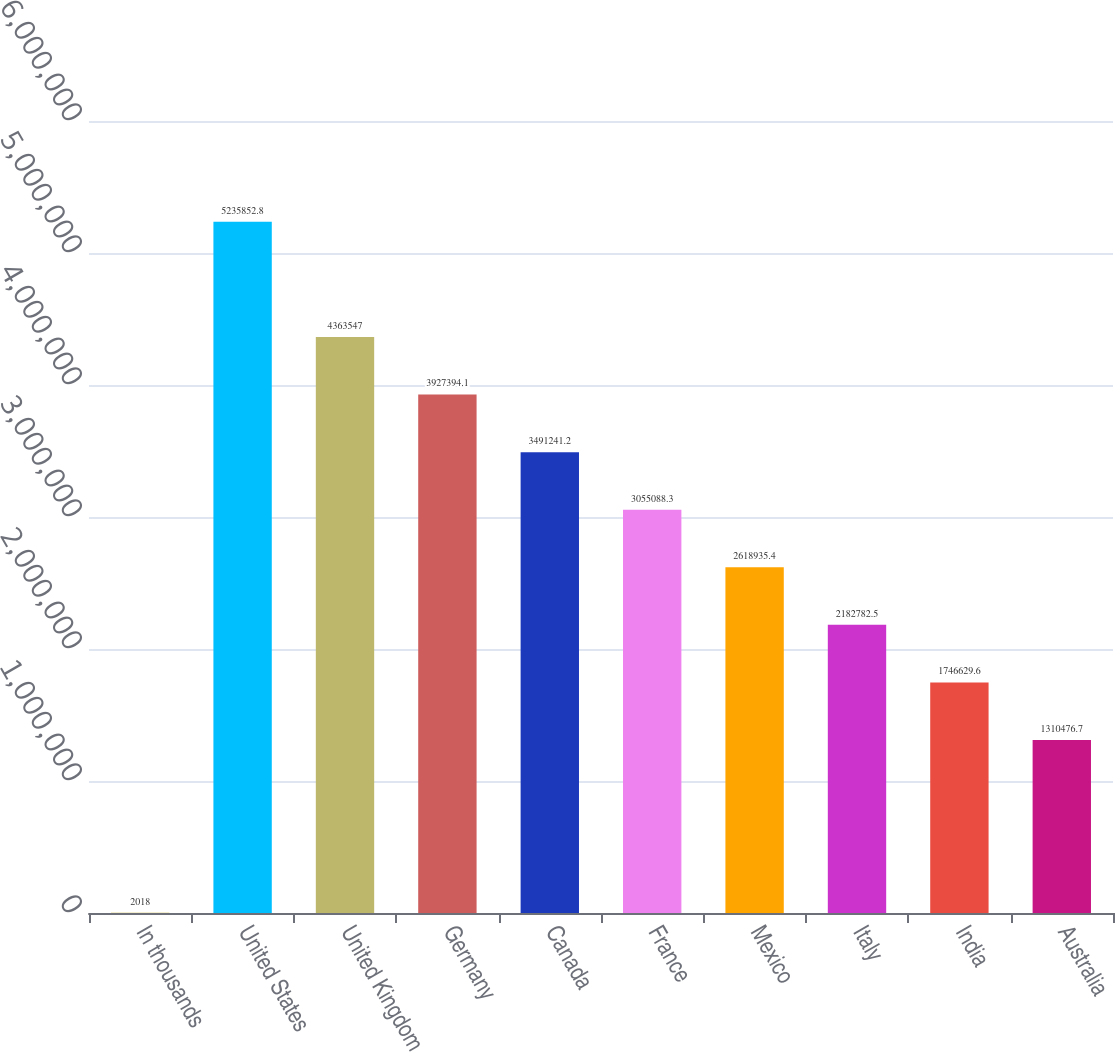Convert chart to OTSL. <chart><loc_0><loc_0><loc_500><loc_500><bar_chart><fcel>In thousands<fcel>United States<fcel>United Kingdom<fcel>Germany<fcel>Canada<fcel>France<fcel>Mexico<fcel>Italy<fcel>India<fcel>Australia<nl><fcel>2018<fcel>5.23585e+06<fcel>4.36355e+06<fcel>3.92739e+06<fcel>3.49124e+06<fcel>3.05509e+06<fcel>2.61894e+06<fcel>2.18278e+06<fcel>1.74663e+06<fcel>1.31048e+06<nl></chart> 